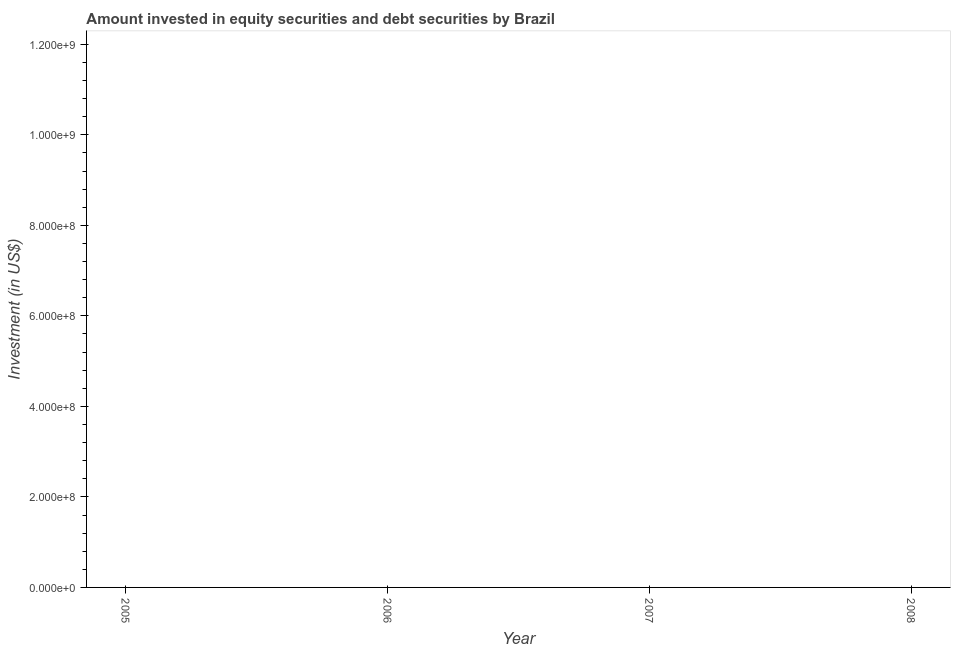What is the portfolio investment in 2006?
Give a very brief answer. 0. What is the sum of the portfolio investment?
Offer a very short reply. 0. How many years are there in the graph?
Your response must be concise. 4. Are the values on the major ticks of Y-axis written in scientific E-notation?
Offer a very short reply. Yes. Does the graph contain any zero values?
Your answer should be compact. Yes. What is the title of the graph?
Ensure brevity in your answer.  Amount invested in equity securities and debt securities by Brazil. What is the label or title of the Y-axis?
Your answer should be compact. Investment (in US$). 